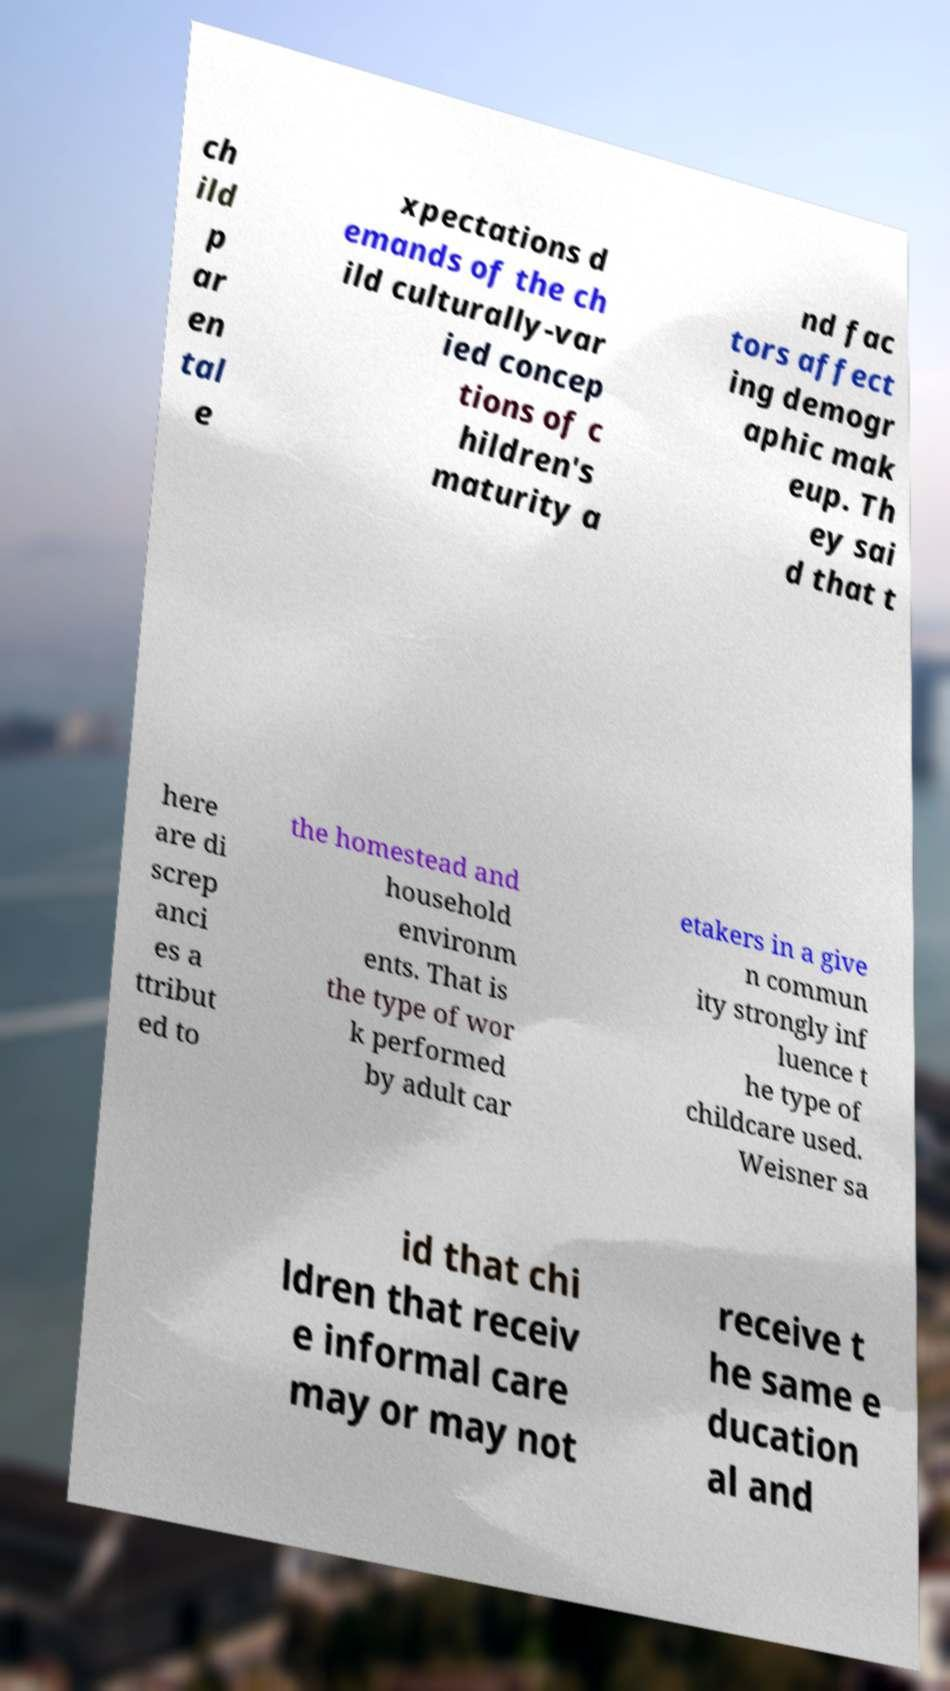For documentation purposes, I need the text within this image transcribed. Could you provide that? ch ild p ar en tal e xpectations d emands of the ch ild culturally-var ied concep tions of c hildren's maturity a nd fac tors affect ing demogr aphic mak eup. Th ey sai d that t here are di screp anci es a ttribut ed to the homestead and household environm ents. That is the type of wor k performed by adult car etakers in a give n commun ity strongly inf luence t he type of childcare used. Weisner sa id that chi ldren that receiv e informal care may or may not receive t he same e ducation al and 